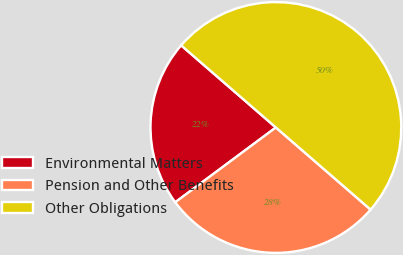<chart> <loc_0><loc_0><loc_500><loc_500><pie_chart><fcel>Environmental Matters<fcel>Pension and Other Benefits<fcel>Other Obligations<nl><fcel>21.54%<fcel>28.46%<fcel>50.0%<nl></chart> 